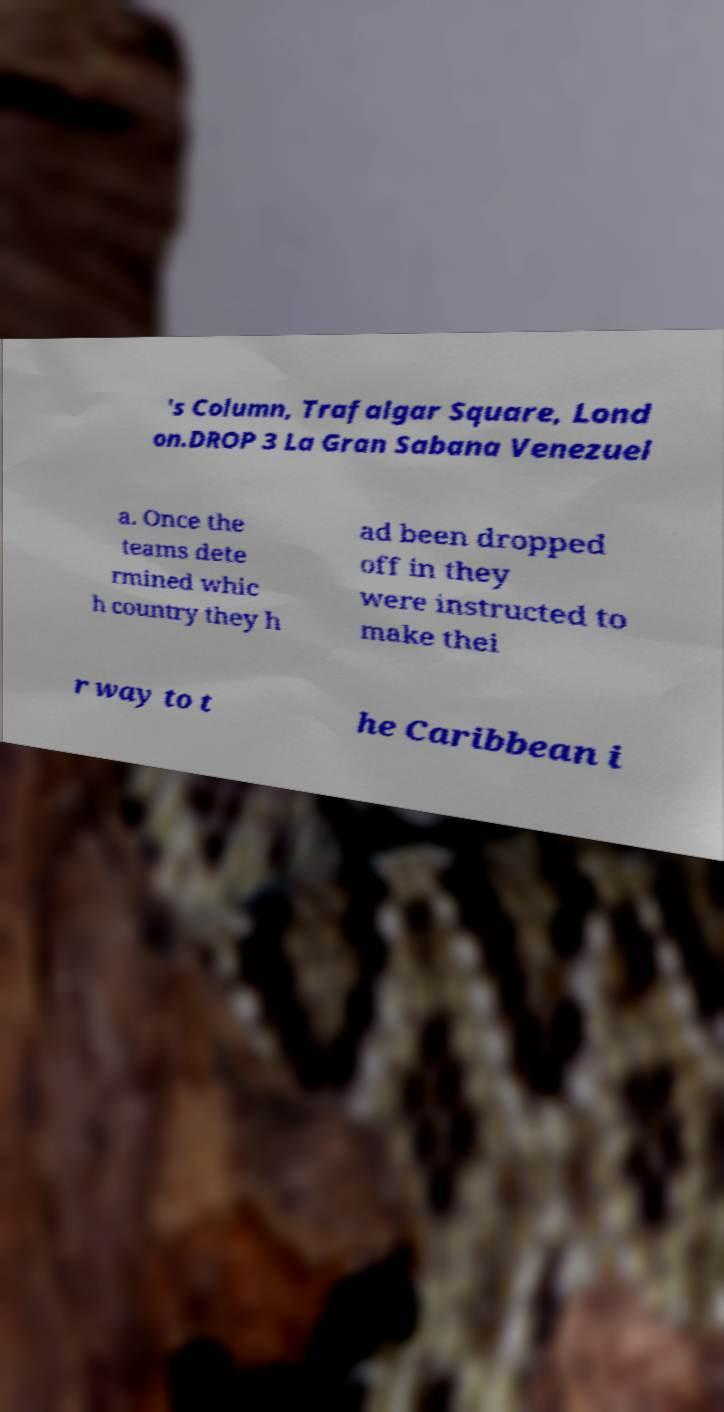Can you accurately transcribe the text from the provided image for me? 's Column, Trafalgar Square, Lond on.DROP 3 La Gran Sabana Venezuel a. Once the teams dete rmined whic h country they h ad been dropped off in they were instructed to make thei r way to t he Caribbean i 